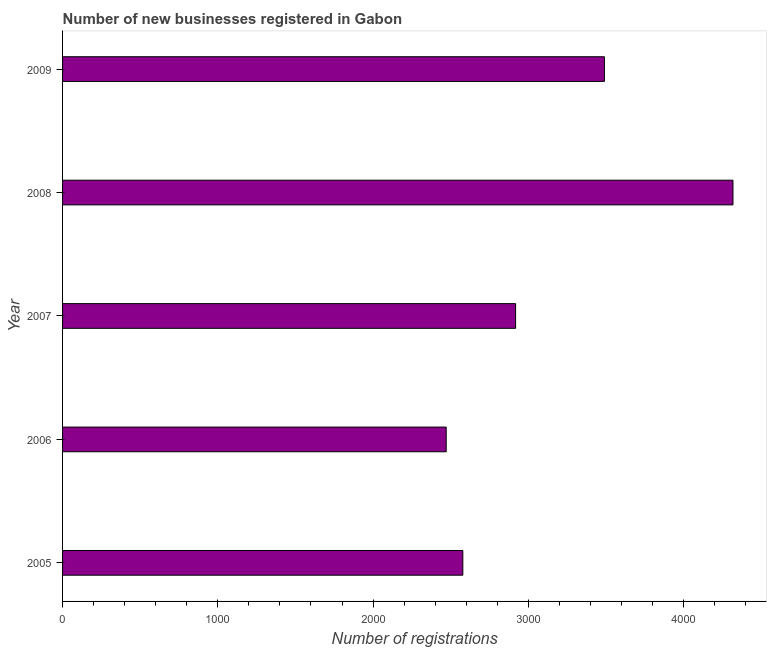Does the graph contain any zero values?
Provide a short and direct response. No. What is the title of the graph?
Ensure brevity in your answer.  Number of new businesses registered in Gabon. What is the label or title of the X-axis?
Offer a terse response. Number of registrations. What is the label or title of the Y-axis?
Keep it short and to the point. Year. What is the number of new business registrations in 2009?
Your answer should be very brief. 3490. Across all years, what is the maximum number of new business registrations?
Your response must be concise. 4318. Across all years, what is the minimum number of new business registrations?
Give a very brief answer. 2471. In which year was the number of new business registrations maximum?
Your answer should be compact. 2008. In which year was the number of new business registrations minimum?
Make the answer very short. 2006. What is the sum of the number of new business registrations?
Offer a very short reply. 1.58e+04. What is the difference between the number of new business registrations in 2006 and 2009?
Ensure brevity in your answer.  -1019. What is the average number of new business registrations per year?
Offer a terse response. 3155. What is the median number of new business registrations?
Make the answer very short. 2918. In how many years, is the number of new business registrations greater than 200 ?
Ensure brevity in your answer.  5. Do a majority of the years between 2008 and 2007 (inclusive) have number of new business registrations greater than 2000 ?
Offer a terse response. No. What is the ratio of the number of new business registrations in 2006 to that in 2009?
Provide a short and direct response. 0.71. Is the number of new business registrations in 2006 less than that in 2009?
Ensure brevity in your answer.  Yes. What is the difference between the highest and the second highest number of new business registrations?
Offer a very short reply. 828. Is the sum of the number of new business registrations in 2005 and 2007 greater than the maximum number of new business registrations across all years?
Your answer should be very brief. Yes. What is the difference between the highest and the lowest number of new business registrations?
Offer a terse response. 1847. In how many years, is the number of new business registrations greater than the average number of new business registrations taken over all years?
Your answer should be very brief. 2. How many bars are there?
Offer a terse response. 5. Are all the bars in the graph horizontal?
Offer a very short reply. Yes. How many years are there in the graph?
Offer a terse response. 5. What is the difference between two consecutive major ticks on the X-axis?
Give a very brief answer. 1000. What is the Number of registrations in 2005?
Give a very brief answer. 2578. What is the Number of registrations of 2006?
Keep it short and to the point. 2471. What is the Number of registrations in 2007?
Offer a very short reply. 2918. What is the Number of registrations in 2008?
Keep it short and to the point. 4318. What is the Number of registrations in 2009?
Keep it short and to the point. 3490. What is the difference between the Number of registrations in 2005 and 2006?
Make the answer very short. 107. What is the difference between the Number of registrations in 2005 and 2007?
Offer a terse response. -340. What is the difference between the Number of registrations in 2005 and 2008?
Ensure brevity in your answer.  -1740. What is the difference between the Number of registrations in 2005 and 2009?
Your response must be concise. -912. What is the difference between the Number of registrations in 2006 and 2007?
Offer a very short reply. -447. What is the difference between the Number of registrations in 2006 and 2008?
Your answer should be very brief. -1847. What is the difference between the Number of registrations in 2006 and 2009?
Offer a very short reply. -1019. What is the difference between the Number of registrations in 2007 and 2008?
Provide a succinct answer. -1400. What is the difference between the Number of registrations in 2007 and 2009?
Provide a succinct answer. -572. What is the difference between the Number of registrations in 2008 and 2009?
Provide a short and direct response. 828. What is the ratio of the Number of registrations in 2005 to that in 2006?
Make the answer very short. 1.04. What is the ratio of the Number of registrations in 2005 to that in 2007?
Provide a succinct answer. 0.88. What is the ratio of the Number of registrations in 2005 to that in 2008?
Provide a short and direct response. 0.6. What is the ratio of the Number of registrations in 2005 to that in 2009?
Provide a short and direct response. 0.74. What is the ratio of the Number of registrations in 2006 to that in 2007?
Provide a succinct answer. 0.85. What is the ratio of the Number of registrations in 2006 to that in 2008?
Make the answer very short. 0.57. What is the ratio of the Number of registrations in 2006 to that in 2009?
Your response must be concise. 0.71. What is the ratio of the Number of registrations in 2007 to that in 2008?
Provide a succinct answer. 0.68. What is the ratio of the Number of registrations in 2007 to that in 2009?
Ensure brevity in your answer.  0.84. What is the ratio of the Number of registrations in 2008 to that in 2009?
Offer a very short reply. 1.24. 